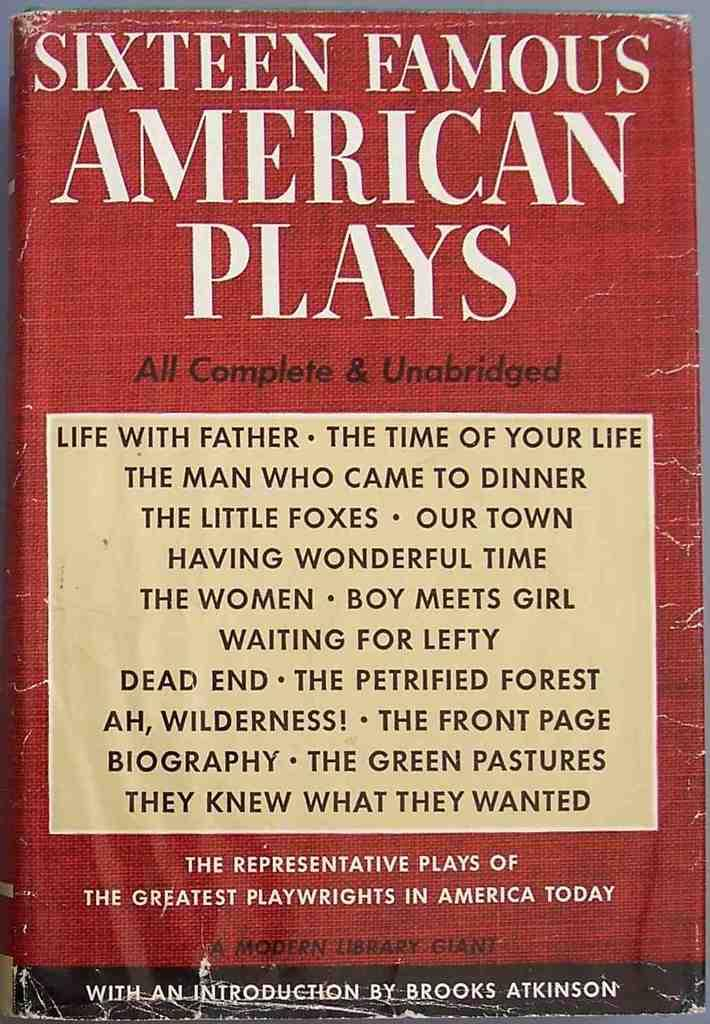<image>
Describe the image concisely. The book Sixteen Famous American Plays with a torn up cover. 